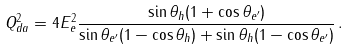Convert formula to latex. <formula><loc_0><loc_0><loc_500><loc_500>Q ^ { 2 } _ { d a } = 4 E _ { e } ^ { 2 } \frac { \sin \theta _ { h } ( 1 + \cos \theta _ { e ^ { \prime } } ) } { \sin \theta _ { e ^ { \prime } } ( 1 - \cos \theta _ { h } ) + \sin \theta _ { h } ( 1 - \cos \theta _ { e ^ { \prime } } ) } \, .</formula> 